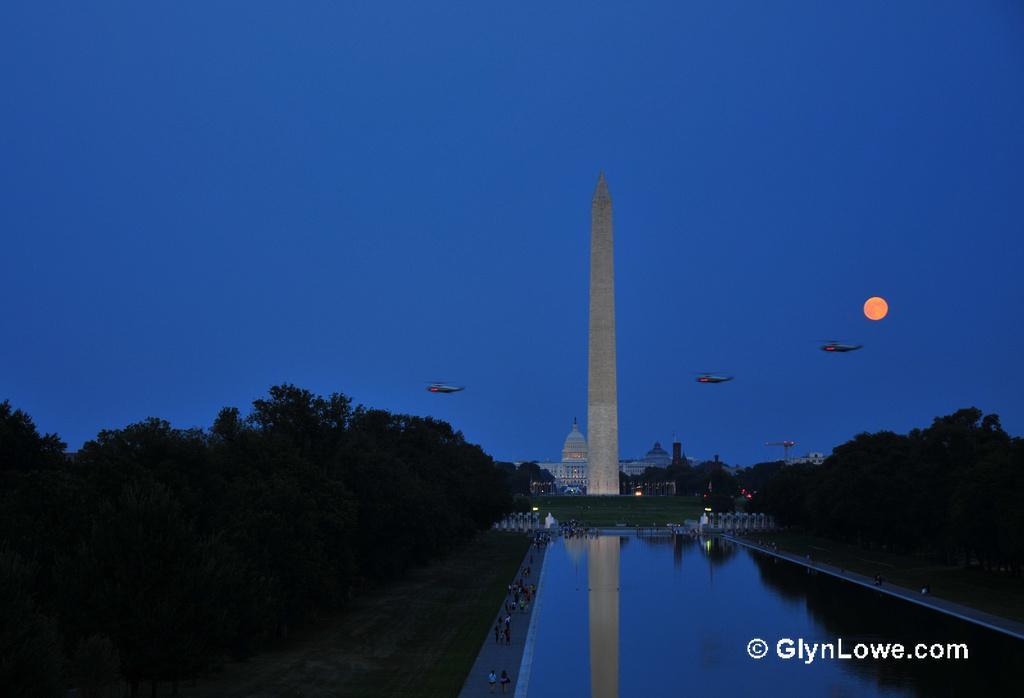Could you give a brief overview of what you see in this image? In the image we can see there is a water on the both sides there are trees and and there are helicopters flying in the sky. Behind there is a building and people standing on the footpath. 